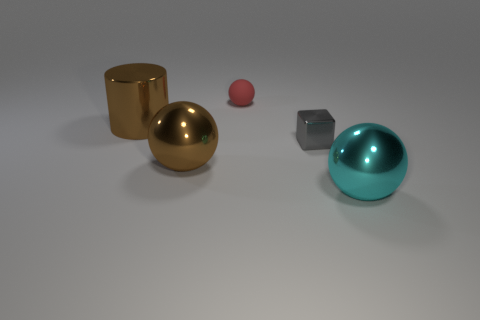How many small blue rubber objects are there?
Provide a succinct answer. 0. There is a big thing that is right of the matte object; what color is it?
Your answer should be compact. Cyan. The big thing behind the large metal ball that is to the left of the tiny red matte object is what color?
Offer a very short reply. Brown. There is a metallic ball that is the same size as the cyan shiny thing; what color is it?
Provide a short and direct response. Brown. How many big metallic objects are both on the left side of the metallic block and in front of the brown metal cylinder?
Provide a succinct answer. 1. What shape is the big metal object that is the same color as the metallic cylinder?
Your response must be concise. Sphere. There is a sphere that is right of the large brown metallic ball and to the left of the cyan metal object; what material is it?
Ensure brevity in your answer.  Rubber. Is the number of big cyan metallic balls in front of the cyan metal sphere less than the number of small red spheres that are behind the red rubber ball?
Ensure brevity in your answer.  No. There is a brown cylinder that is the same material as the brown sphere; what is its size?
Your answer should be very brief. Large. Is there anything else of the same color as the cylinder?
Your response must be concise. Yes. 